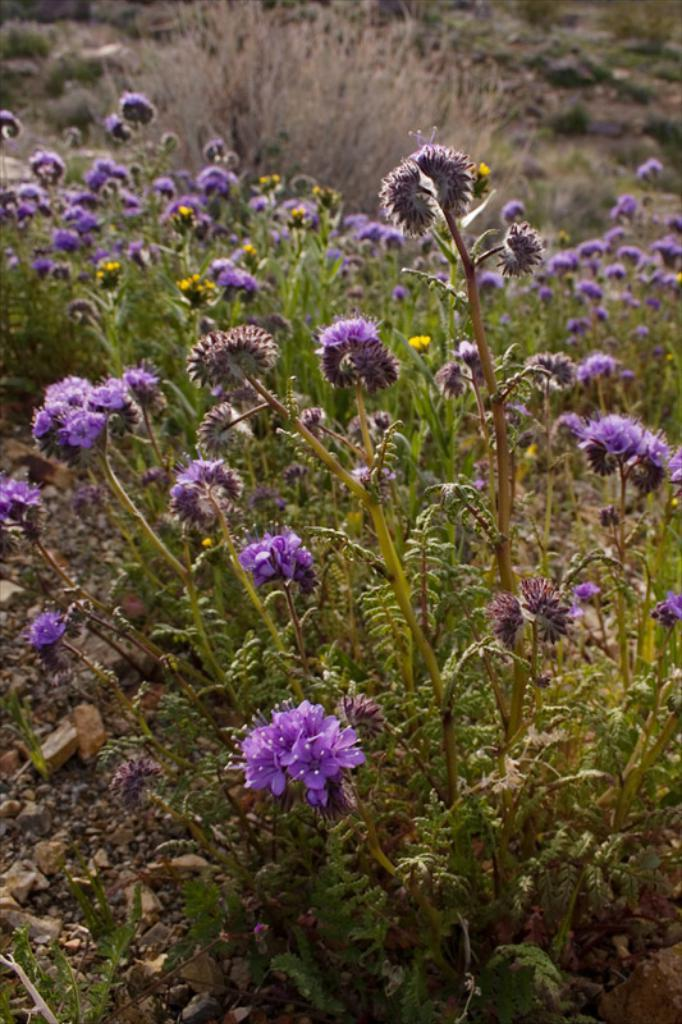What type of plants are visible in the image? There are many flowers on plants in the image. Can you describe the flowers in more detail? Unfortunately, the facts provided do not give specific details about the flowers. Are there any other objects or elements in the image besides the flowers? The facts provided do not mention any other objects or elements in the image. How does the porter assist the passengers in the image? There is no porter or passengers present in the image; it only features many flowers on plants. 